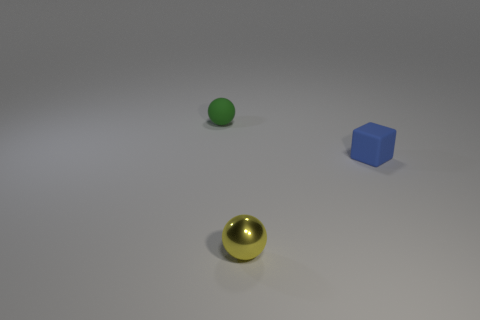Are there the same number of tiny yellow things that are to the right of the green matte thing and small shiny objects?
Your response must be concise. Yes. How many things are both on the left side of the block and behind the tiny yellow shiny ball?
Offer a terse response. 1. What is the size of the blue cube that is the same material as the green object?
Provide a succinct answer. Small. How many other small matte things have the same shape as the yellow object?
Provide a short and direct response. 1. Are there more cubes that are to the right of the tiny block than small blocks?
Provide a short and direct response. No. The small object that is to the right of the tiny green sphere and behind the yellow metallic object has what shape?
Ensure brevity in your answer.  Cube. Do the yellow object and the blue block have the same size?
Ensure brevity in your answer.  Yes. What number of small rubber spheres are in front of the small yellow metallic sphere?
Make the answer very short. 0. Are there the same number of blue blocks that are in front of the tiny blue matte block and metal objects that are to the right of the small yellow thing?
Offer a terse response. Yes. Is the shape of the matte object on the right side of the metal ball the same as  the small yellow object?
Provide a short and direct response. No. 